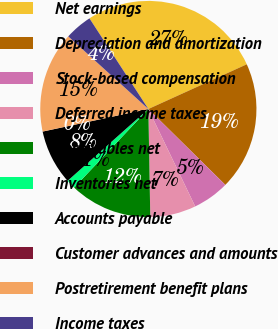<chart> <loc_0><loc_0><loc_500><loc_500><pie_chart><fcel>Net earnings<fcel>Depreciation and amortization<fcel>Stock-based compensation<fcel>Deferred income taxes<fcel>Receivables net<fcel>Inventories net<fcel>Accounts payable<fcel>Customer advances and amounts<fcel>Postretirement benefit plans<fcel>Income taxes<nl><fcel>27.38%<fcel>19.17%<fcel>5.48%<fcel>6.85%<fcel>12.33%<fcel>1.38%<fcel>8.22%<fcel>0.01%<fcel>15.06%<fcel>4.11%<nl></chart> 